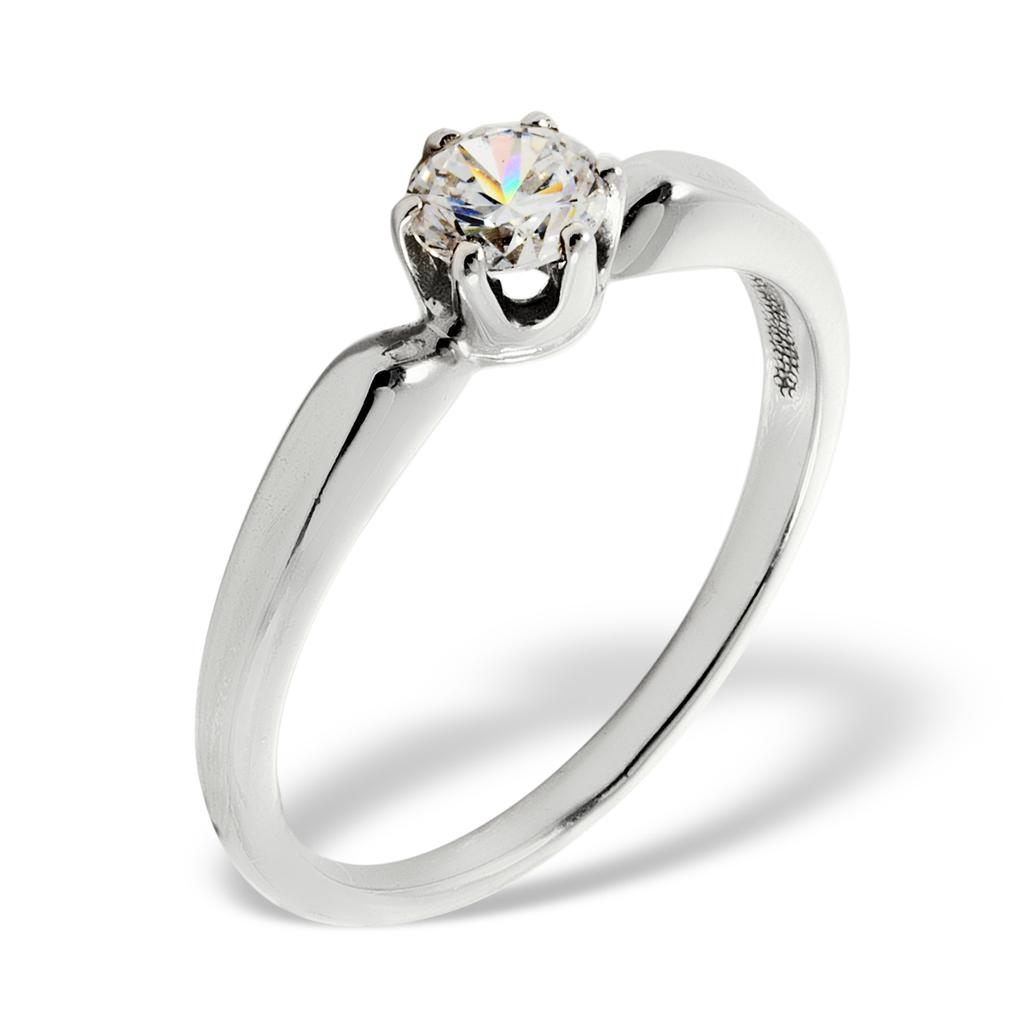What is the main subject in the image? There is a white color ring in the image. How many balls are visible in the image? There are no balls present in the image; it only features a white color ring. What type of tree can be seen in the image? There is no tree present in the image; it only features a white color ring. 